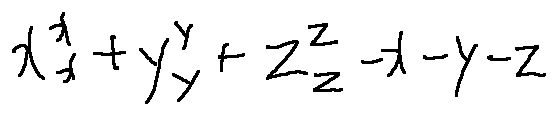Convert formula to latex. <formula><loc_0><loc_0><loc_500><loc_500>x _ { x } ^ { x } + y _ { y } ^ { y } + z _ { z } ^ { z } - x - y - z</formula> 